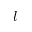Convert formula to latex. <formula><loc_0><loc_0><loc_500><loc_500>l</formula> 